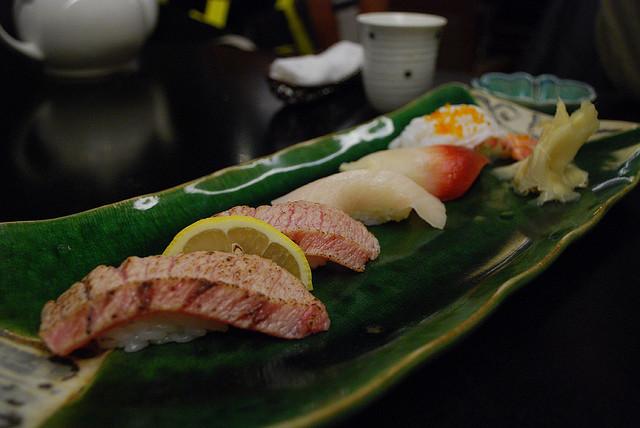Are the portions bite sized?
Be succinct. Yes. What is edible in the pic?
Keep it brief. Food. Is tea available?
Short answer required. Yes. What is the color of the plate?
Answer briefly. Green. What kind of food is this?
Write a very short answer. Sushi. 